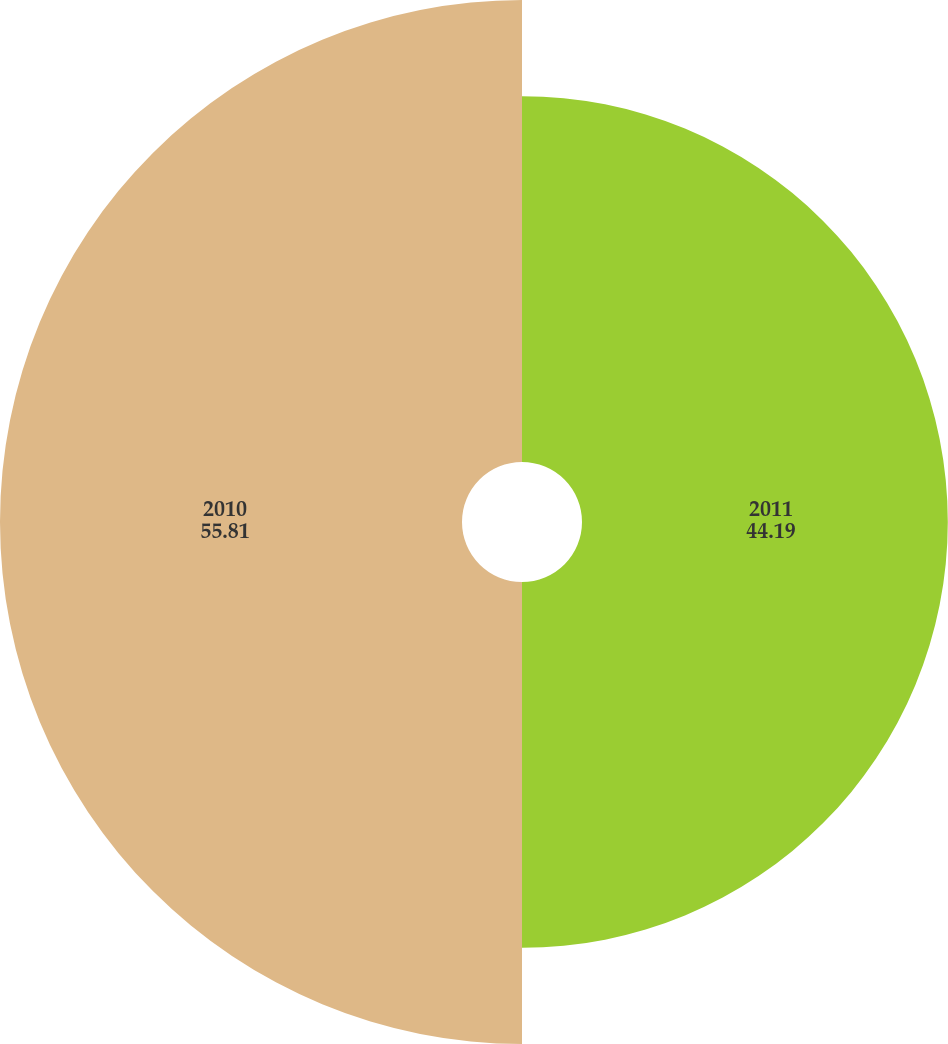Convert chart to OTSL. <chart><loc_0><loc_0><loc_500><loc_500><pie_chart><fcel>2011<fcel>2010<nl><fcel>44.19%<fcel>55.81%<nl></chart> 